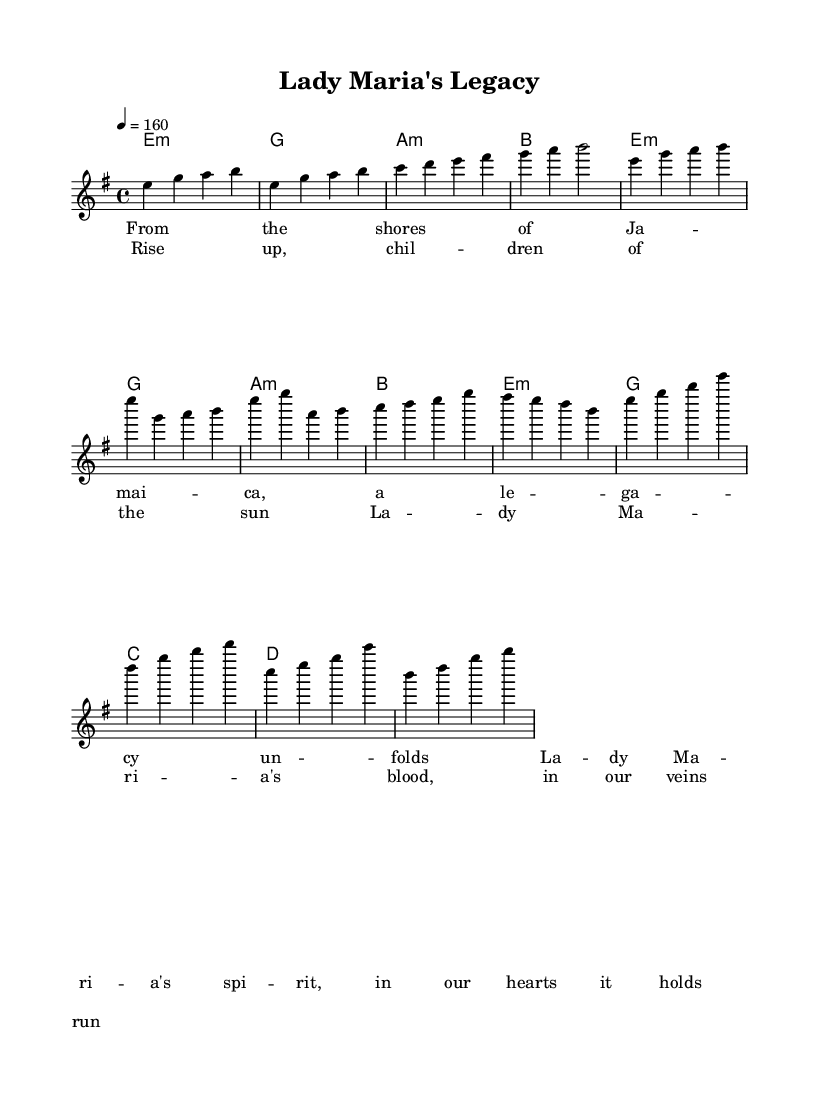What is the key signature of this music? The key signature is E minor, which has one sharp (F#) and is indicated at the beginning of the staff.
Answer: E minor What is the time signature? The time signature is 4/4, as shown at the beginning of the score, indicating four beats in each measure.
Answer: 4/4 What is the tempo marking? The tempo marking is 4 equals 160, meaning the quarter note gets 160 beats per minute.
Answer: 160 How many measures are in the Intro section? The Intro section consists of four measures, as evident from the notation provided before the Verse begins.
Answer: 4 In the Chorus, what chord follows the G chord? The chord that follows G in the Chorus is C, which directly follows the G chord in the harmonic progression.
Answer: C What phrase begins the Chorus lyrics? The Chorus lyrics begin with "Rise up, children of the sun," which is the first line and indicates the thematic shift in the song.
Answer: Rise up, children of the sun What musical genre does this song belong to? The song belongs to the genre of power metal, as it typically features epic themes and complex musical structures characteristic of the style.
Answer: Power metal 